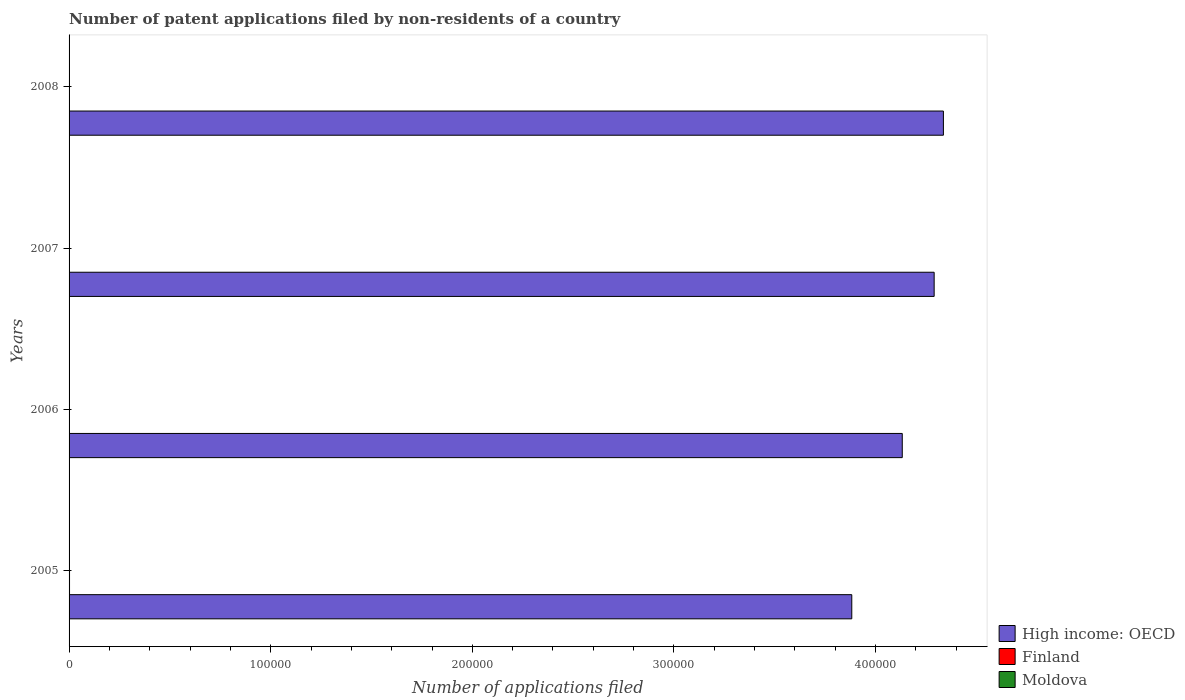How many different coloured bars are there?
Ensure brevity in your answer.  3. Are the number of bars per tick equal to the number of legend labels?
Ensure brevity in your answer.  Yes. What is the label of the 1st group of bars from the top?
Provide a succinct answer. 2008. In how many cases, is the number of bars for a given year not equal to the number of legend labels?
Keep it short and to the point. 0. What is the number of applications filed in Finland in 2006?
Provide a succinct answer. 202. Across all years, what is the maximum number of applications filed in Finland?
Your response must be concise. 229. Across all years, what is the minimum number of applications filed in Finland?
Provide a short and direct response. 147. In which year was the number of applications filed in Moldova maximum?
Give a very brief answer. 2008. What is the total number of applications filed in Moldova in the graph?
Provide a short and direct response. 56. What is the difference between the number of applications filed in High income: OECD in 2005 and the number of applications filed in Moldova in 2008?
Ensure brevity in your answer.  3.88e+05. What is the average number of applications filed in Moldova per year?
Make the answer very short. 14. In the year 2007, what is the difference between the number of applications filed in High income: OECD and number of applications filed in Finland?
Your answer should be compact. 4.29e+05. In how many years, is the number of applications filed in Finland greater than 220000 ?
Offer a very short reply. 0. What is the ratio of the number of applications filed in Finland in 2007 to that in 2008?
Give a very brief answer. 1.44. What is the difference between the highest and the second highest number of applications filed in Finland?
Provide a short and direct response. 18. What is the difference between the highest and the lowest number of applications filed in Finland?
Offer a terse response. 82. In how many years, is the number of applications filed in Moldova greater than the average number of applications filed in Moldova taken over all years?
Your answer should be compact. 1. What does the 1st bar from the bottom in 2006 represents?
Offer a terse response. High income: OECD. Is it the case that in every year, the sum of the number of applications filed in Moldova and number of applications filed in High income: OECD is greater than the number of applications filed in Finland?
Provide a short and direct response. Yes. Are all the bars in the graph horizontal?
Ensure brevity in your answer.  Yes. What is the difference between two consecutive major ticks on the X-axis?
Give a very brief answer. 1.00e+05. Are the values on the major ticks of X-axis written in scientific E-notation?
Your response must be concise. No. Does the graph contain any zero values?
Give a very brief answer. No. Does the graph contain grids?
Give a very brief answer. No. How are the legend labels stacked?
Your answer should be very brief. Vertical. What is the title of the graph?
Your answer should be very brief. Number of patent applications filed by non-residents of a country. What is the label or title of the X-axis?
Offer a very short reply. Number of applications filed. What is the label or title of the Y-axis?
Your response must be concise. Years. What is the Number of applications filed of High income: OECD in 2005?
Ensure brevity in your answer.  3.88e+05. What is the Number of applications filed of Finland in 2005?
Give a very brief answer. 229. What is the Number of applications filed in High income: OECD in 2006?
Your response must be concise. 4.13e+05. What is the Number of applications filed in Finland in 2006?
Make the answer very short. 202. What is the Number of applications filed in High income: OECD in 2007?
Keep it short and to the point. 4.29e+05. What is the Number of applications filed of Finland in 2007?
Make the answer very short. 211. What is the Number of applications filed in Moldova in 2007?
Provide a succinct answer. 14. What is the Number of applications filed in High income: OECD in 2008?
Your answer should be compact. 4.34e+05. What is the Number of applications filed of Finland in 2008?
Ensure brevity in your answer.  147. Across all years, what is the maximum Number of applications filed of High income: OECD?
Your answer should be compact. 4.34e+05. Across all years, what is the maximum Number of applications filed of Finland?
Make the answer very short. 229. Across all years, what is the maximum Number of applications filed of Moldova?
Provide a succinct answer. 22. Across all years, what is the minimum Number of applications filed in High income: OECD?
Keep it short and to the point. 3.88e+05. Across all years, what is the minimum Number of applications filed in Finland?
Offer a very short reply. 147. Across all years, what is the minimum Number of applications filed of Moldova?
Provide a short and direct response. 9. What is the total Number of applications filed of High income: OECD in the graph?
Provide a short and direct response. 1.66e+06. What is the total Number of applications filed of Finland in the graph?
Ensure brevity in your answer.  789. What is the difference between the Number of applications filed of High income: OECD in 2005 and that in 2006?
Offer a very short reply. -2.50e+04. What is the difference between the Number of applications filed of Finland in 2005 and that in 2006?
Your response must be concise. 27. What is the difference between the Number of applications filed in High income: OECD in 2005 and that in 2007?
Your answer should be compact. -4.09e+04. What is the difference between the Number of applications filed of High income: OECD in 2005 and that in 2008?
Make the answer very short. -4.54e+04. What is the difference between the Number of applications filed in Finland in 2005 and that in 2008?
Make the answer very short. 82. What is the difference between the Number of applications filed in High income: OECD in 2006 and that in 2007?
Provide a short and direct response. -1.58e+04. What is the difference between the Number of applications filed of High income: OECD in 2006 and that in 2008?
Offer a very short reply. -2.04e+04. What is the difference between the Number of applications filed in High income: OECD in 2007 and that in 2008?
Keep it short and to the point. -4587. What is the difference between the Number of applications filed of High income: OECD in 2005 and the Number of applications filed of Finland in 2006?
Provide a succinct answer. 3.88e+05. What is the difference between the Number of applications filed of High income: OECD in 2005 and the Number of applications filed of Moldova in 2006?
Offer a very short reply. 3.88e+05. What is the difference between the Number of applications filed of Finland in 2005 and the Number of applications filed of Moldova in 2006?
Provide a succinct answer. 220. What is the difference between the Number of applications filed in High income: OECD in 2005 and the Number of applications filed in Finland in 2007?
Ensure brevity in your answer.  3.88e+05. What is the difference between the Number of applications filed in High income: OECD in 2005 and the Number of applications filed in Moldova in 2007?
Your answer should be compact. 3.88e+05. What is the difference between the Number of applications filed in Finland in 2005 and the Number of applications filed in Moldova in 2007?
Offer a very short reply. 215. What is the difference between the Number of applications filed of High income: OECD in 2005 and the Number of applications filed of Finland in 2008?
Offer a terse response. 3.88e+05. What is the difference between the Number of applications filed in High income: OECD in 2005 and the Number of applications filed in Moldova in 2008?
Your answer should be compact. 3.88e+05. What is the difference between the Number of applications filed in Finland in 2005 and the Number of applications filed in Moldova in 2008?
Ensure brevity in your answer.  207. What is the difference between the Number of applications filed of High income: OECD in 2006 and the Number of applications filed of Finland in 2007?
Your response must be concise. 4.13e+05. What is the difference between the Number of applications filed of High income: OECD in 2006 and the Number of applications filed of Moldova in 2007?
Keep it short and to the point. 4.13e+05. What is the difference between the Number of applications filed in Finland in 2006 and the Number of applications filed in Moldova in 2007?
Provide a succinct answer. 188. What is the difference between the Number of applications filed of High income: OECD in 2006 and the Number of applications filed of Finland in 2008?
Offer a very short reply. 4.13e+05. What is the difference between the Number of applications filed in High income: OECD in 2006 and the Number of applications filed in Moldova in 2008?
Make the answer very short. 4.13e+05. What is the difference between the Number of applications filed of Finland in 2006 and the Number of applications filed of Moldova in 2008?
Give a very brief answer. 180. What is the difference between the Number of applications filed in High income: OECD in 2007 and the Number of applications filed in Finland in 2008?
Make the answer very short. 4.29e+05. What is the difference between the Number of applications filed of High income: OECD in 2007 and the Number of applications filed of Moldova in 2008?
Provide a succinct answer. 4.29e+05. What is the difference between the Number of applications filed of Finland in 2007 and the Number of applications filed of Moldova in 2008?
Your answer should be very brief. 189. What is the average Number of applications filed in High income: OECD per year?
Provide a succinct answer. 4.16e+05. What is the average Number of applications filed in Finland per year?
Offer a terse response. 197.25. In the year 2005, what is the difference between the Number of applications filed of High income: OECD and Number of applications filed of Finland?
Keep it short and to the point. 3.88e+05. In the year 2005, what is the difference between the Number of applications filed in High income: OECD and Number of applications filed in Moldova?
Ensure brevity in your answer.  3.88e+05. In the year 2005, what is the difference between the Number of applications filed in Finland and Number of applications filed in Moldova?
Your answer should be compact. 218. In the year 2006, what is the difference between the Number of applications filed in High income: OECD and Number of applications filed in Finland?
Provide a succinct answer. 4.13e+05. In the year 2006, what is the difference between the Number of applications filed of High income: OECD and Number of applications filed of Moldova?
Give a very brief answer. 4.13e+05. In the year 2006, what is the difference between the Number of applications filed of Finland and Number of applications filed of Moldova?
Your answer should be compact. 193. In the year 2007, what is the difference between the Number of applications filed of High income: OECD and Number of applications filed of Finland?
Make the answer very short. 4.29e+05. In the year 2007, what is the difference between the Number of applications filed in High income: OECD and Number of applications filed in Moldova?
Give a very brief answer. 4.29e+05. In the year 2007, what is the difference between the Number of applications filed of Finland and Number of applications filed of Moldova?
Your response must be concise. 197. In the year 2008, what is the difference between the Number of applications filed of High income: OECD and Number of applications filed of Finland?
Offer a very short reply. 4.33e+05. In the year 2008, what is the difference between the Number of applications filed of High income: OECD and Number of applications filed of Moldova?
Provide a succinct answer. 4.34e+05. In the year 2008, what is the difference between the Number of applications filed of Finland and Number of applications filed of Moldova?
Ensure brevity in your answer.  125. What is the ratio of the Number of applications filed of High income: OECD in 2005 to that in 2006?
Make the answer very short. 0.94. What is the ratio of the Number of applications filed in Finland in 2005 to that in 2006?
Your answer should be compact. 1.13. What is the ratio of the Number of applications filed of Moldova in 2005 to that in 2006?
Your response must be concise. 1.22. What is the ratio of the Number of applications filed of High income: OECD in 2005 to that in 2007?
Your answer should be compact. 0.9. What is the ratio of the Number of applications filed of Finland in 2005 to that in 2007?
Make the answer very short. 1.09. What is the ratio of the Number of applications filed of Moldova in 2005 to that in 2007?
Offer a very short reply. 0.79. What is the ratio of the Number of applications filed in High income: OECD in 2005 to that in 2008?
Provide a short and direct response. 0.9. What is the ratio of the Number of applications filed in Finland in 2005 to that in 2008?
Your answer should be compact. 1.56. What is the ratio of the Number of applications filed of High income: OECD in 2006 to that in 2007?
Your answer should be compact. 0.96. What is the ratio of the Number of applications filed in Finland in 2006 to that in 2007?
Provide a short and direct response. 0.96. What is the ratio of the Number of applications filed of Moldova in 2006 to that in 2007?
Make the answer very short. 0.64. What is the ratio of the Number of applications filed in High income: OECD in 2006 to that in 2008?
Your response must be concise. 0.95. What is the ratio of the Number of applications filed of Finland in 2006 to that in 2008?
Offer a very short reply. 1.37. What is the ratio of the Number of applications filed in Moldova in 2006 to that in 2008?
Make the answer very short. 0.41. What is the ratio of the Number of applications filed of Finland in 2007 to that in 2008?
Your response must be concise. 1.44. What is the ratio of the Number of applications filed in Moldova in 2007 to that in 2008?
Your response must be concise. 0.64. What is the difference between the highest and the second highest Number of applications filed of High income: OECD?
Ensure brevity in your answer.  4587. What is the difference between the highest and the lowest Number of applications filed in High income: OECD?
Your answer should be compact. 4.54e+04. What is the difference between the highest and the lowest Number of applications filed in Moldova?
Offer a terse response. 13. 